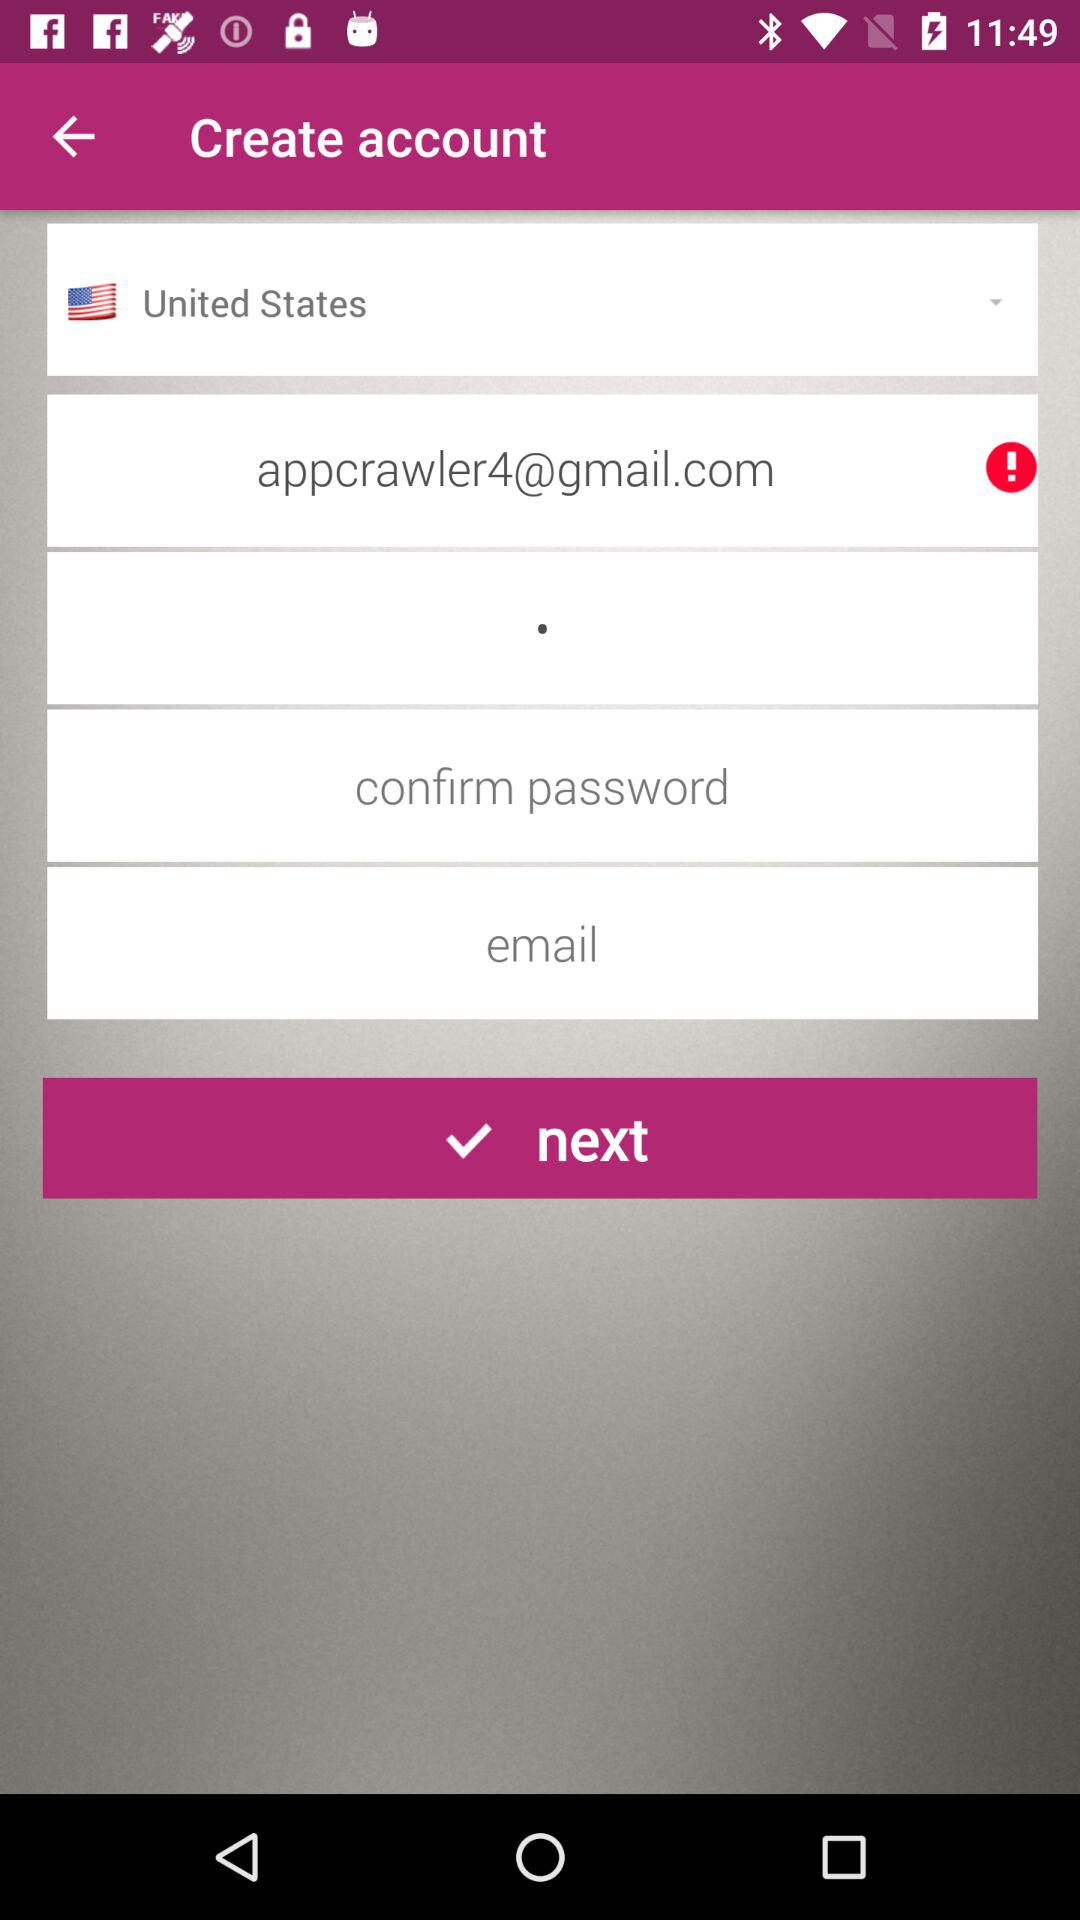What is the e-mail address? The email address is appcrawler4@gmail.com. 